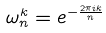<formula> <loc_0><loc_0><loc_500><loc_500>\omega _ { n } ^ { k } = e ^ { - \frac { 2 \pi i k } { n } }</formula> 